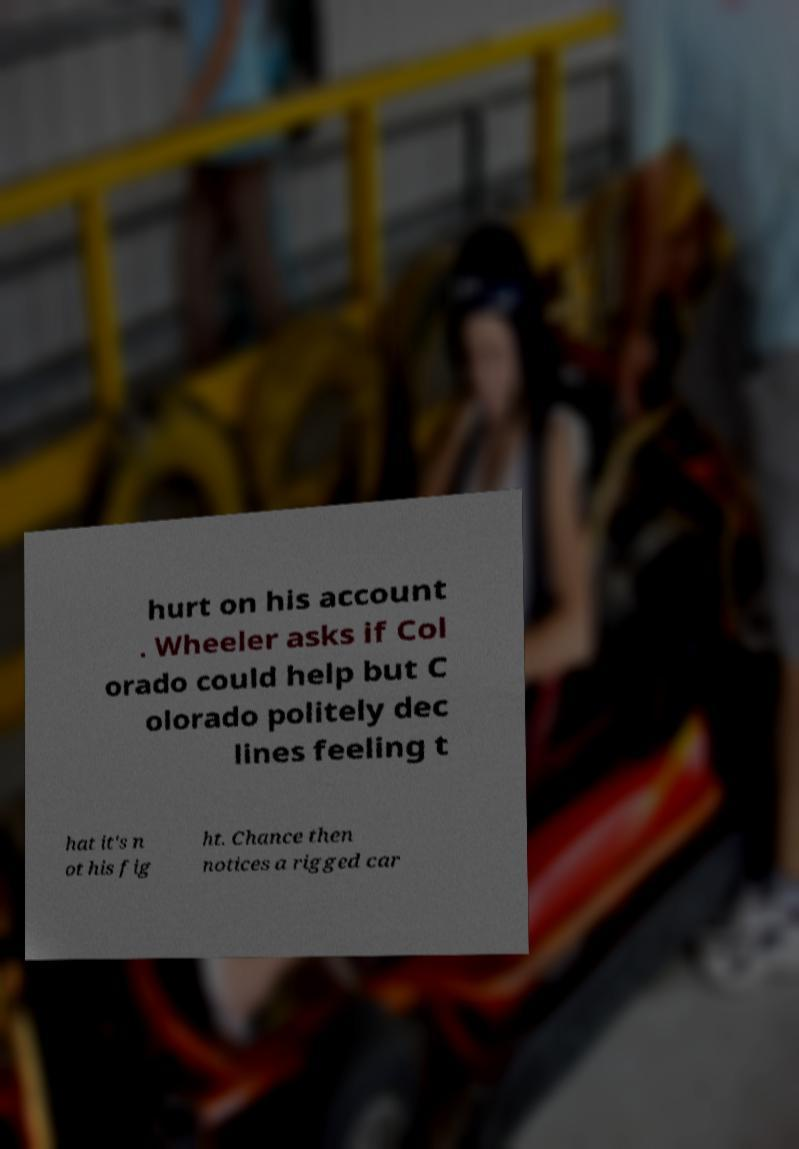Could you assist in decoding the text presented in this image and type it out clearly? hurt on his account . Wheeler asks if Col orado could help but C olorado politely dec lines feeling t hat it's n ot his fig ht. Chance then notices a rigged car 